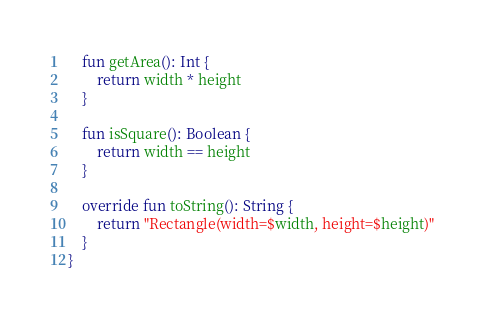<code> <loc_0><loc_0><loc_500><loc_500><_Kotlin_>
    fun getArea(): Int {
        return width * height
    }

    fun isSquare(): Boolean {
        return width == height
    }

    override fun toString(): String {
        return "Rectangle(width=$width, height=$height)"
    }
}
</code> 